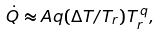Convert formula to latex. <formula><loc_0><loc_0><loc_500><loc_500>\dot { Q } \approx A q ( \Delta T / T _ { r } ) T _ { r } ^ { \, q } ,</formula> 